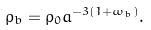Convert formula to latex. <formula><loc_0><loc_0><loc_500><loc_500>\rho _ { b } = \rho _ { 0 } a ^ { - 3 ( 1 + \omega _ { b } ) } .</formula> 